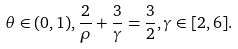Convert formula to latex. <formula><loc_0><loc_0><loc_500><loc_500>\theta \in ( 0 , 1 ) , \frac { 2 } { \rho } + \frac { 3 } { \gamma } = \frac { 3 } { 2 } , \gamma \in [ 2 , 6 ] .</formula> 